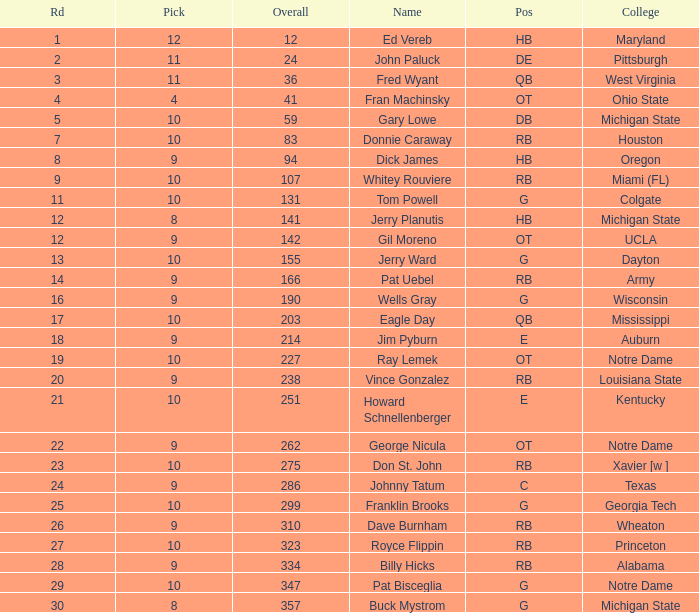What is the highest overall pick number for george nicula who had a pick smaller than 9? None. 